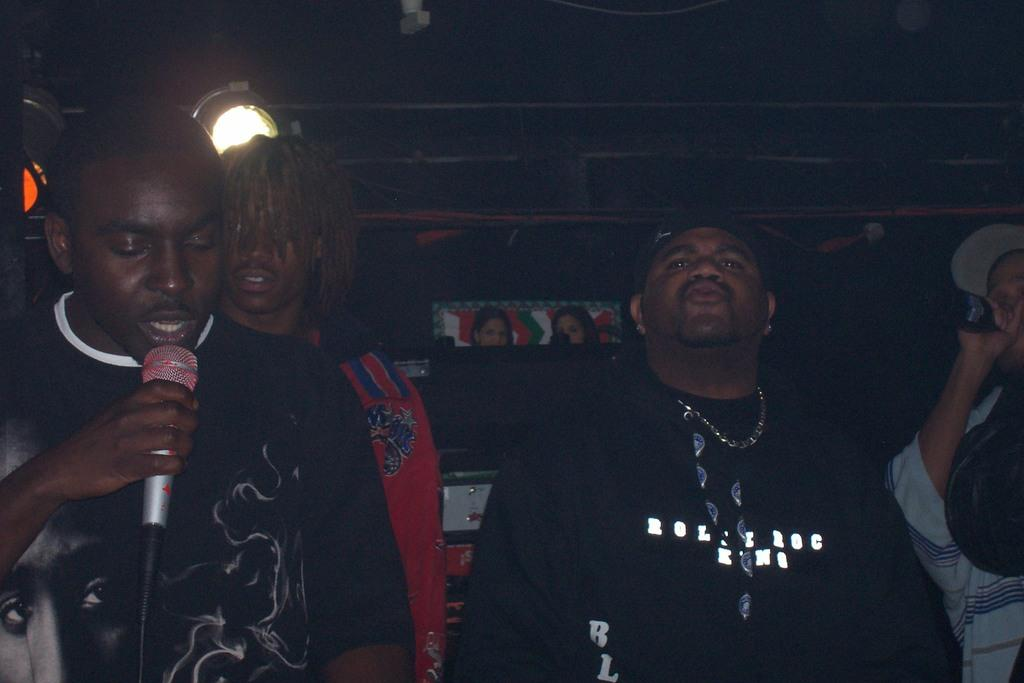How many people are in the image? There are people standing in the image. What is one person doing in the image? One person is holding a microphone. What is the person holding the microphone doing? The person holding the microphone is singing. What can be seen in the background of the image? There are lights visible in the background. Can you see any yaks in the image? There are no yaks present in the image. What type of branch is being used by the person holding the microphone? There is no branch visible in the image; the person is holding a microphone. 